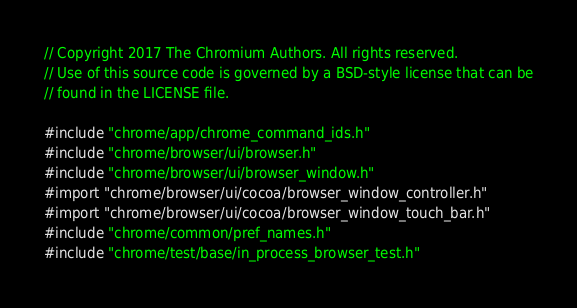<code> <loc_0><loc_0><loc_500><loc_500><_ObjectiveC_>// Copyright 2017 The Chromium Authors. All rights reserved.
// Use of this source code is governed by a BSD-style license that can be
// found in the LICENSE file.

#include "chrome/app/chrome_command_ids.h"
#include "chrome/browser/ui/browser.h"
#include "chrome/browser/ui/browser_window.h"
#import "chrome/browser/ui/cocoa/browser_window_controller.h"
#import "chrome/browser/ui/cocoa/browser_window_touch_bar.h"
#include "chrome/common/pref_names.h"
#include "chrome/test/base/in_process_browser_test.h"</code> 